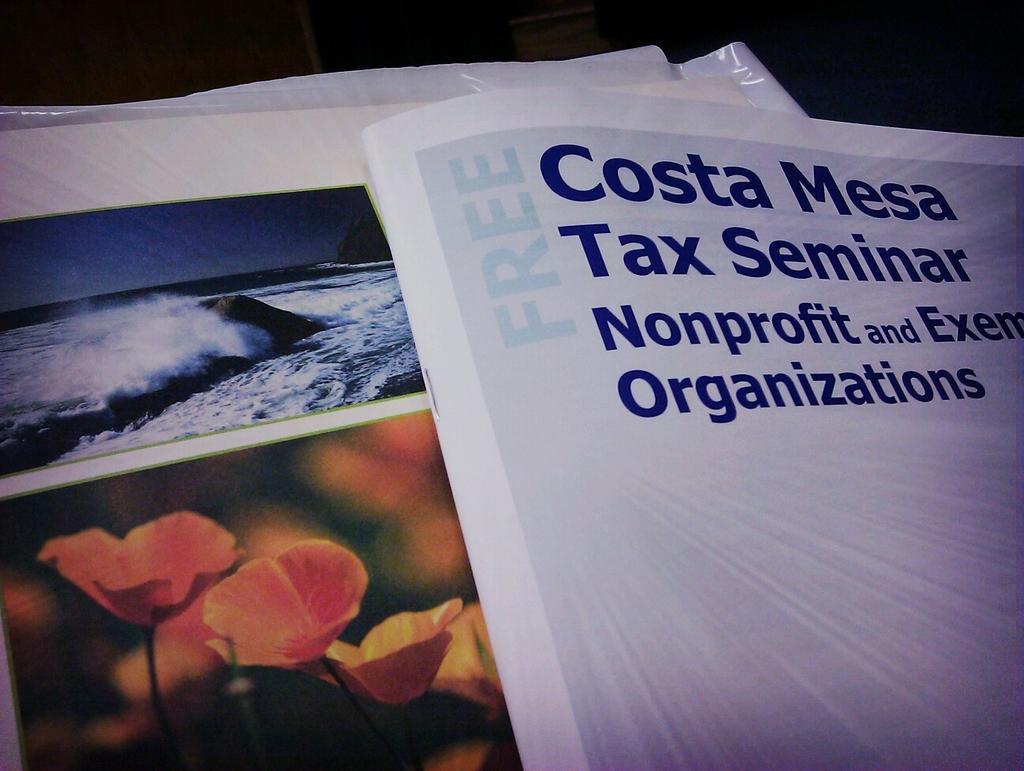Could you give a brief overview of what you see in this image? In this image we can see books with text and image. 